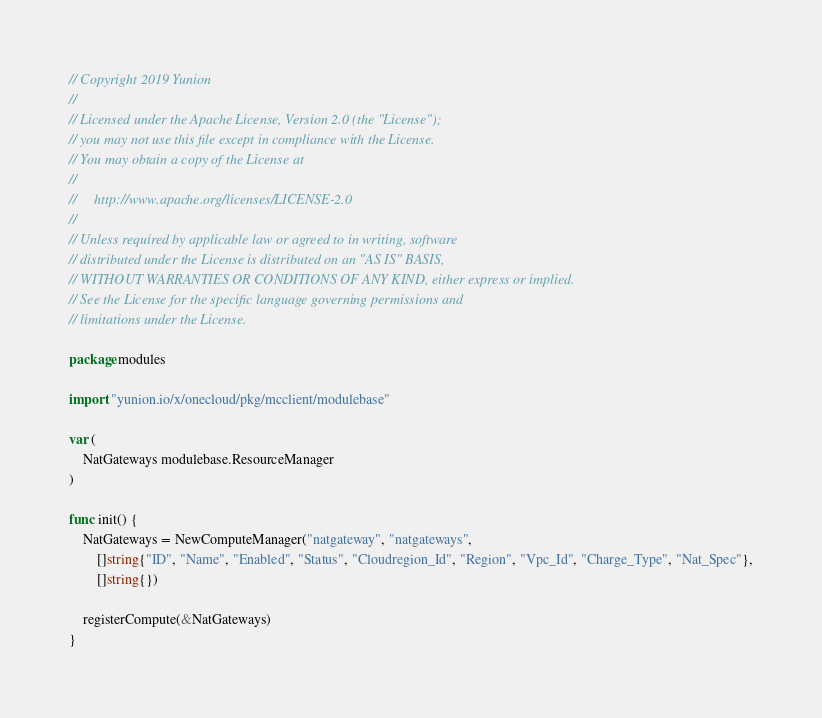Convert code to text. <code><loc_0><loc_0><loc_500><loc_500><_Go_>// Copyright 2019 Yunion
//
// Licensed under the Apache License, Version 2.0 (the "License");
// you may not use this file except in compliance with the License.
// You may obtain a copy of the License at
//
//     http://www.apache.org/licenses/LICENSE-2.0
//
// Unless required by applicable law or agreed to in writing, software
// distributed under the License is distributed on an "AS IS" BASIS,
// WITHOUT WARRANTIES OR CONDITIONS OF ANY KIND, either express or implied.
// See the License for the specific language governing permissions and
// limitations under the License.

package modules

import "yunion.io/x/onecloud/pkg/mcclient/modulebase"

var (
	NatGateways modulebase.ResourceManager
)

func init() {
	NatGateways = NewComputeManager("natgateway", "natgateways",
		[]string{"ID", "Name", "Enabled", "Status", "Cloudregion_Id", "Region", "Vpc_Id", "Charge_Type", "Nat_Spec"},
		[]string{})

	registerCompute(&NatGateways)
}
</code> 